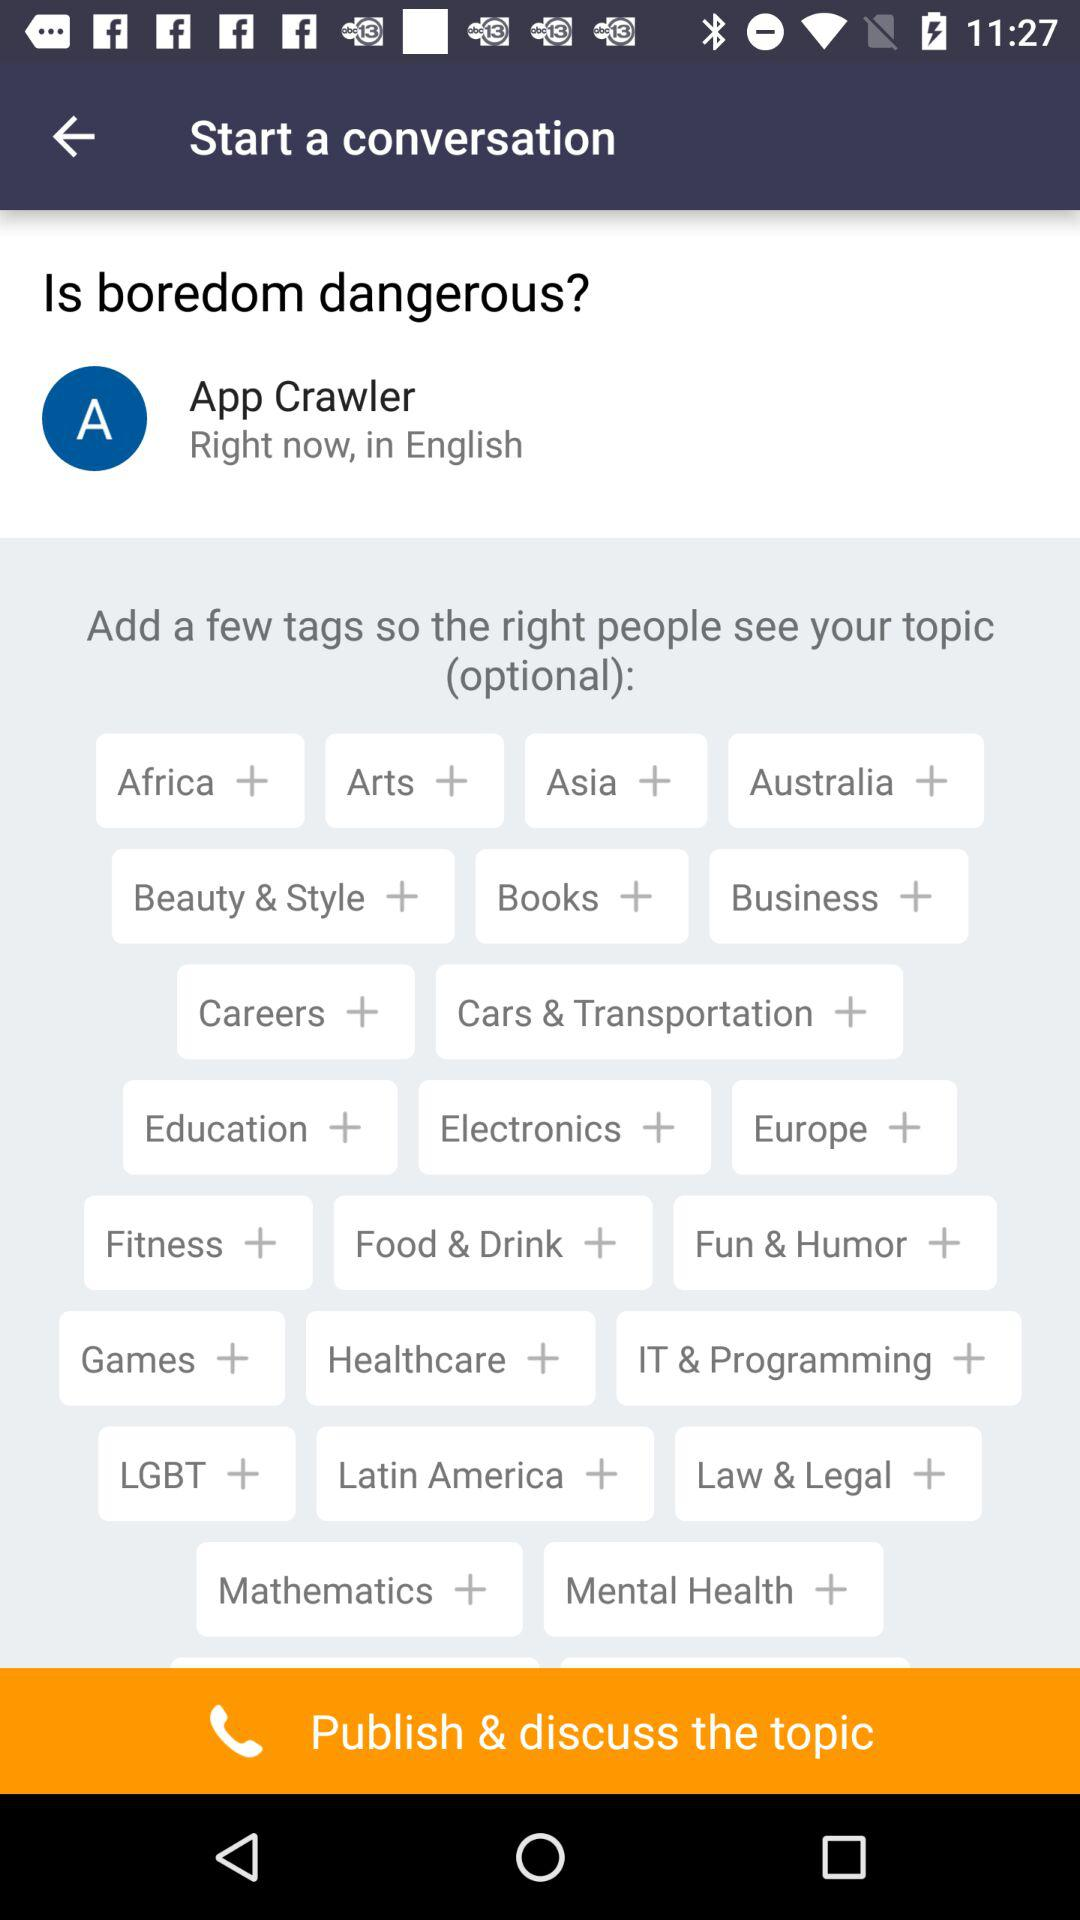What are the tags shown on the screen? The tags shown on the screen are "Africa", "Arts", "Asia", "Australia", "Beauty & Style", "Books", "Business", "Careers", "Cars & Transportation", "Education", "Electronics", "Europe", "Fitness", "Food & Drink", "Fun & Humor", "Games", "Healthcare", "IT & Programming", "LGBT", "Latin America", "Law & Legal", "Mathematics" and "Mental Health". 